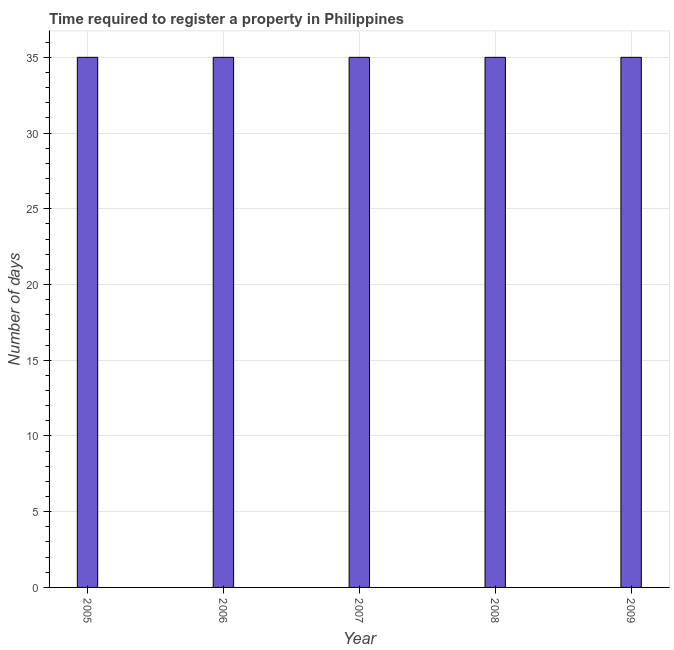Does the graph contain any zero values?
Offer a terse response. No. What is the title of the graph?
Keep it short and to the point. Time required to register a property in Philippines. What is the label or title of the X-axis?
Provide a succinct answer. Year. What is the label or title of the Y-axis?
Provide a short and direct response. Number of days. Across all years, what is the minimum number of days required to register property?
Make the answer very short. 35. In which year was the number of days required to register property minimum?
Your answer should be compact. 2005. What is the sum of the number of days required to register property?
Your response must be concise. 175. What is the difference between the number of days required to register property in 2007 and 2008?
Ensure brevity in your answer.  0. What is the average number of days required to register property per year?
Ensure brevity in your answer.  35. In how many years, is the number of days required to register property greater than 13 days?
Provide a short and direct response. 5. Do a majority of the years between 2008 and 2007 (inclusive) have number of days required to register property greater than 33 days?
Make the answer very short. No. What is the ratio of the number of days required to register property in 2005 to that in 2006?
Give a very brief answer. 1. Is the difference between the number of days required to register property in 2006 and 2008 greater than the difference between any two years?
Your answer should be very brief. Yes. What is the difference between the highest and the second highest number of days required to register property?
Your answer should be very brief. 0. In how many years, is the number of days required to register property greater than the average number of days required to register property taken over all years?
Offer a very short reply. 0. How many bars are there?
Make the answer very short. 5. Are all the bars in the graph horizontal?
Provide a succinct answer. No. What is the Number of days in 2005?
Your answer should be very brief. 35. What is the Number of days in 2006?
Provide a succinct answer. 35. What is the Number of days in 2007?
Provide a succinct answer. 35. What is the Number of days in 2008?
Your answer should be compact. 35. What is the difference between the Number of days in 2005 and 2006?
Give a very brief answer. 0. What is the difference between the Number of days in 2005 and 2008?
Offer a very short reply. 0. What is the difference between the Number of days in 2006 and 2008?
Make the answer very short. 0. What is the difference between the Number of days in 2006 and 2009?
Your response must be concise. 0. What is the difference between the Number of days in 2008 and 2009?
Make the answer very short. 0. What is the ratio of the Number of days in 2005 to that in 2007?
Provide a short and direct response. 1. What is the ratio of the Number of days in 2005 to that in 2008?
Provide a short and direct response. 1. What is the ratio of the Number of days in 2006 to that in 2009?
Ensure brevity in your answer.  1. What is the ratio of the Number of days in 2007 to that in 2008?
Offer a terse response. 1. What is the ratio of the Number of days in 2008 to that in 2009?
Your answer should be compact. 1. 